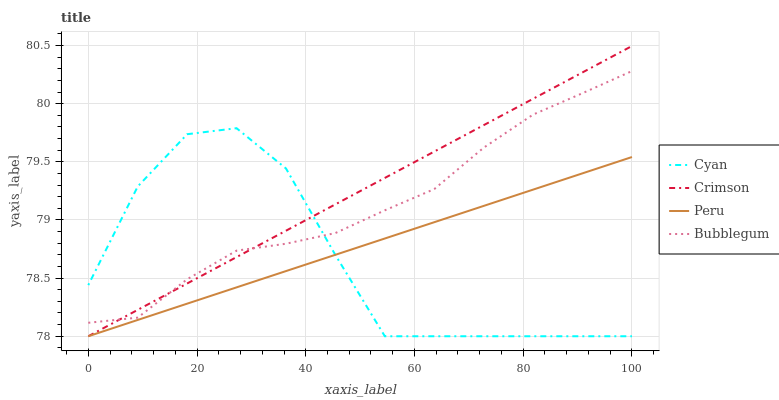Does Cyan have the minimum area under the curve?
Answer yes or no. Yes. Does Crimson have the maximum area under the curve?
Answer yes or no. Yes. Does Bubblegum have the minimum area under the curve?
Answer yes or no. No. Does Bubblegum have the maximum area under the curve?
Answer yes or no. No. Is Crimson the smoothest?
Answer yes or no. Yes. Is Cyan the roughest?
Answer yes or no. Yes. Is Bubblegum the smoothest?
Answer yes or no. No. Is Bubblegum the roughest?
Answer yes or no. No. Does Crimson have the lowest value?
Answer yes or no. Yes. Does Bubblegum have the lowest value?
Answer yes or no. No. Does Crimson have the highest value?
Answer yes or no. Yes. Does Cyan have the highest value?
Answer yes or no. No. Is Peru less than Bubblegum?
Answer yes or no. Yes. Is Bubblegum greater than Peru?
Answer yes or no. Yes. Does Peru intersect Crimson?
Answer yes or no. Yes. Is Peru less than Crimson?
Answer yes or no. No. Is Peru greater than Crimson?
Answer yes or no. No. Does Peru intersect Bubblegum?
Answer yes or no. No. 